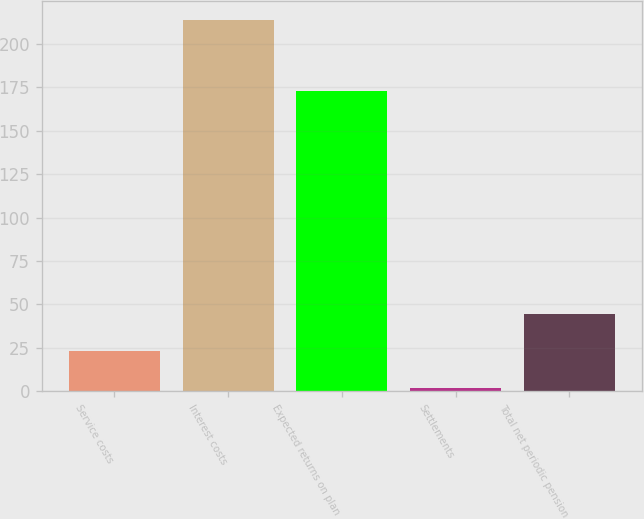<chart> <loc_0><loc_0><loc_500><loc_500><bar_chart><fcel>Service costs<fcel>Interest costs<fcel>Expected returns on plan<fcel>Settlements<fcel>Total net periodic pension<nl><fcel>23.2<fcel>214<fcel>173<fcel>2<fcel>44.4<nl></chart> 